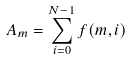<formula> <loc_0><loc_0><loc_500><loc_500>A _ { m } = \sum _ { i = 0 } ^ { N - 1 } f ( m , i )</formula> 